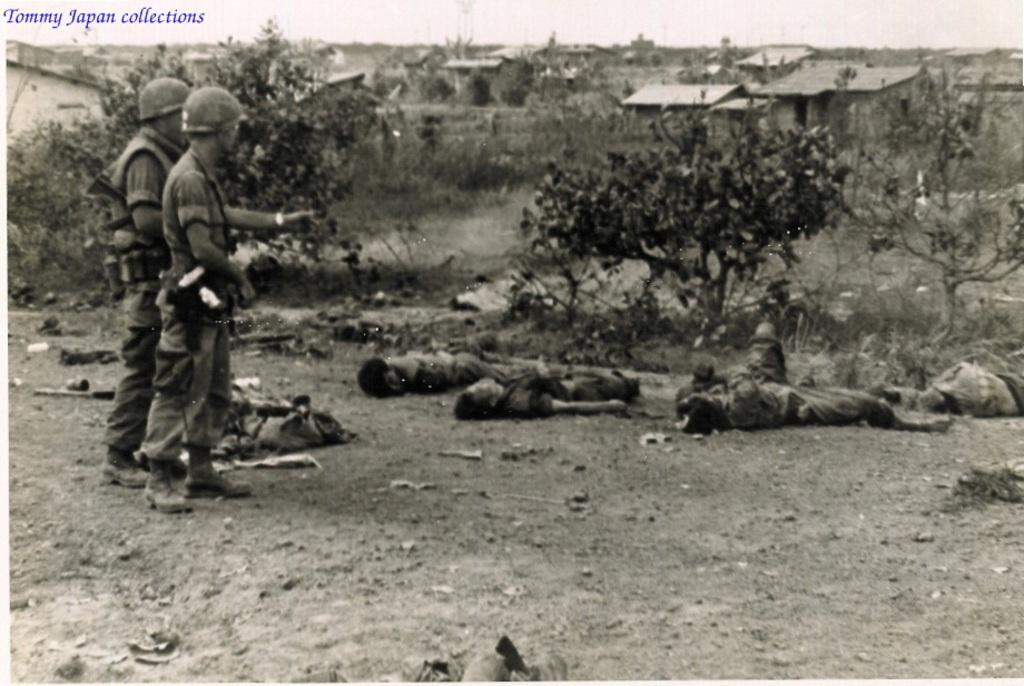How many men are present in the image? There are two men standing in the image. What are the men wearing on their heads? The men are wearing hard hats. Can you describe the people on the ground in the image? There are people on the ground in the image, but their specific actions or appearances are not mentioned in the facts. What can be seen in the background of the image? There are houses and trees in the background of the image. What type of pot is being used to enforce the rule in the image? There is no pot or rule mentioned in the image; it features two men wearing hard hats and people on the ground, with houses and trees in the background. 